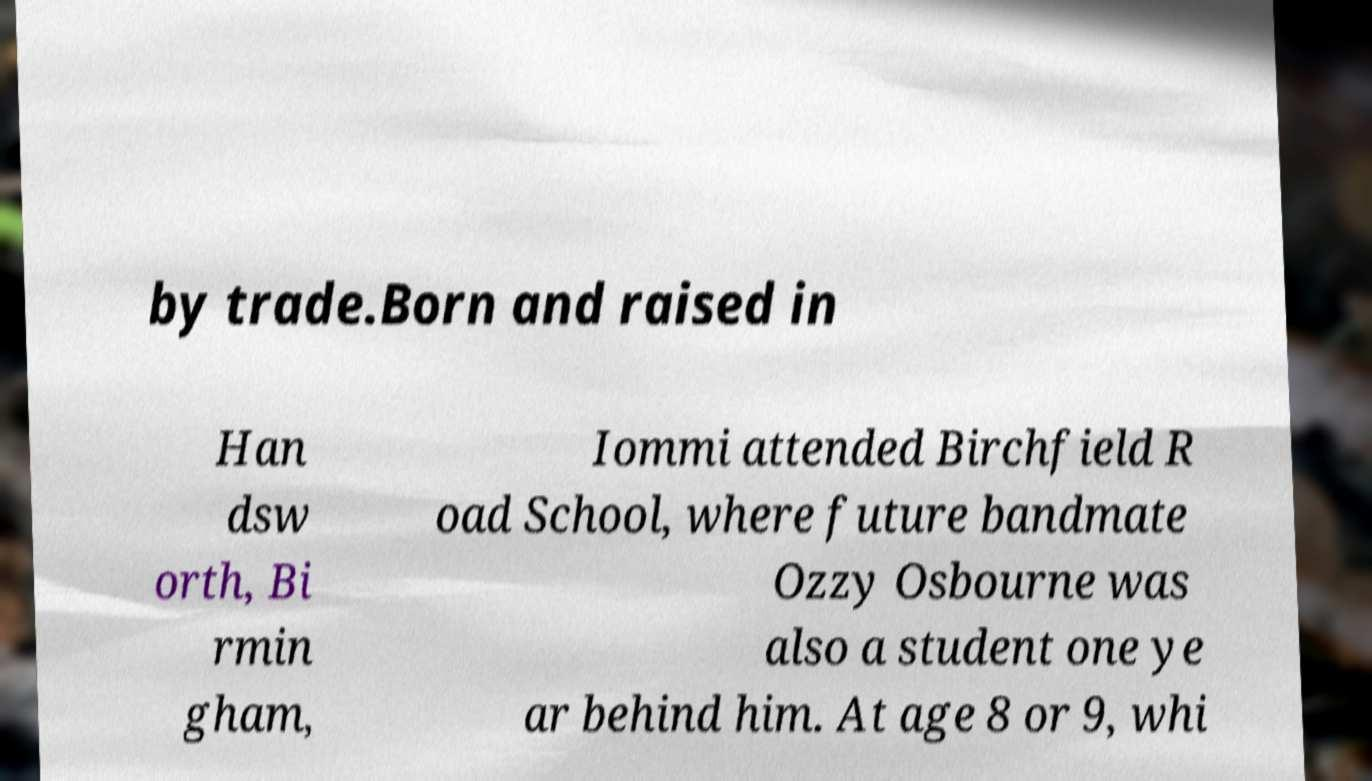Please identify and transcribe the text found in this image. by trade.Born and raised in Han dsw orth, Bi rmin gham, Iommi attended Birchfield R oad School, where future bandmate Ozzy Osbourne was also a student one ye ar behind him. At age 8 or 9, whi 